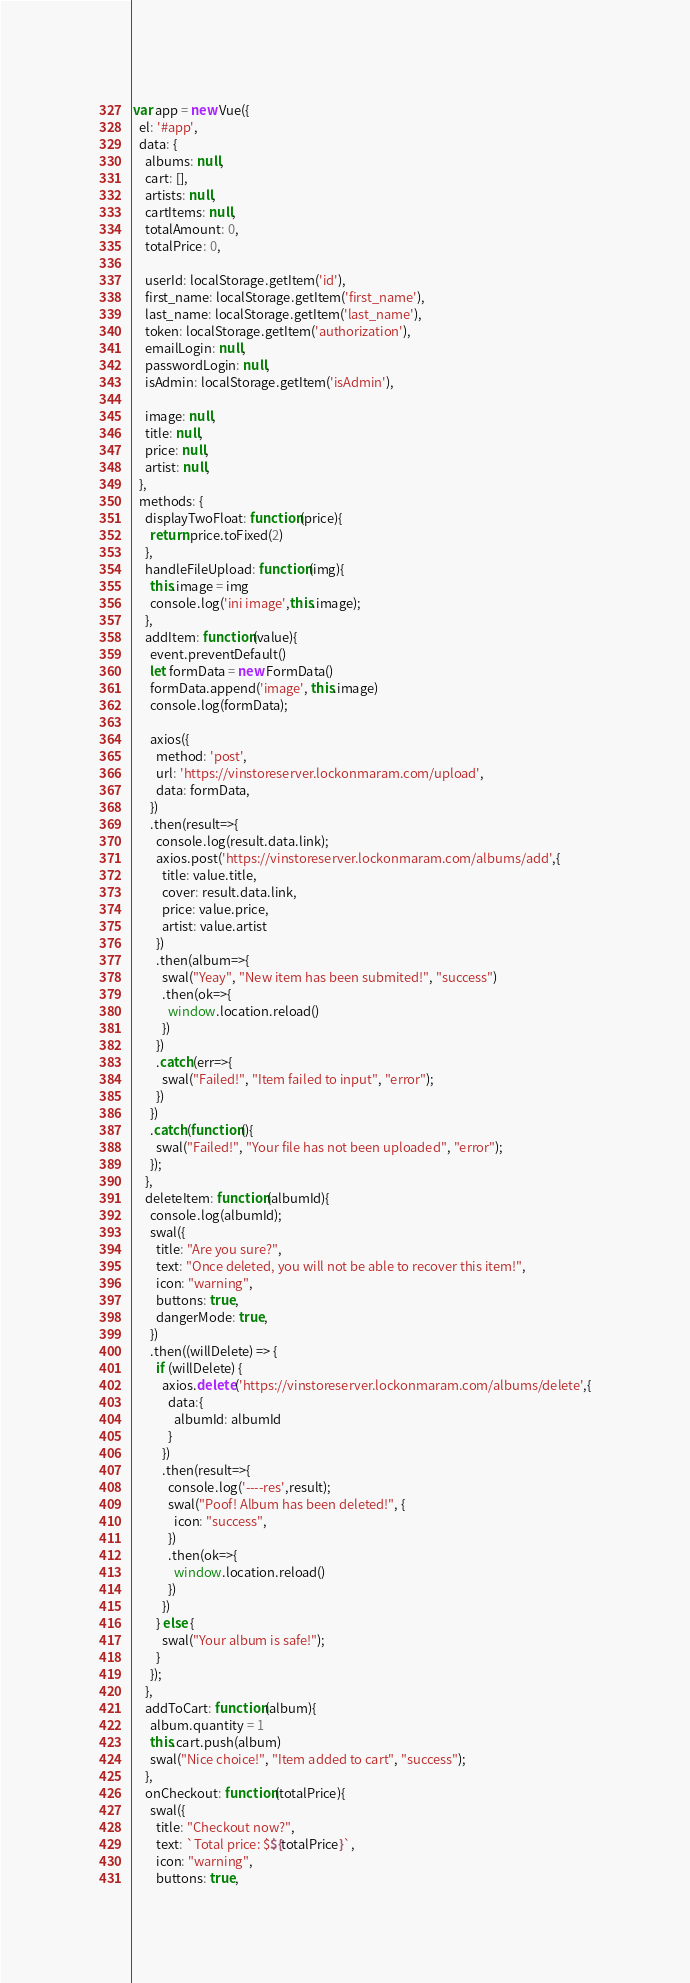<code> <loc_0><loc_0><loc_500><loc_500><_JavaScript_>var app = new Vue({
  el: '#app',
  data: {
    albums: null,
    cart: [],
    artists: null,
    cartItems: null,
    totalAmount: 0,
    totalPrice: 0,

    userId: localStorage.getItem('id'),
    first_name: localStorage.getItem('first_name'),
    last_name: localStorage.getItem('last_name'),
    token: localStorage.getItem('authorization'),
    emailLogin: null,
    passwordLogin: null,
    isAdmin: localStorage.getItem('isAdmin'),

    image: null,
    title: null,
    price: null,
    artist: null,
  },
  methods: {
    displayTwoFloat: function(price){
      return price.toFixed(2)
    },
    handleFileUpload: function(img){
      this.image = img
      console.log('ini image',this.image);
    },
    addItem: function(value){
      event.preventDefault()
      let formData = new FormData()
      formData.append('image', this.image)
      console.log(formData);

      axios({
        method: 'post',
        url: 'https://vinstoreserver.lockonmaram.com/upload',
        data: formData,
      })
      .then(result=>{
        console.log(result.data.link);
        axios.post('https://vinstoreserver.lockonmaram.com/albums/add',{
          title: value.title,
          cover: result.data.link,
          price: value.price,
          artist: value.artist
        })
        .then(album=>{
          swal("Yeay", "New item has been submited!", "success")
          .then(ok=>{
            window.location.reload()
          })
        })
        .catch(err=>{
          swal("Failed!", "Item failed to input", "error");
        })
      })
      .catch(function(){
        swal("Failed!", "Your file has not been uploaded", "error");
      });
    },
    deleteItem: function(albumId){
      console.log(albumId);
      swal({
        title: "Are you sure?",
        text: "Once deleted, you will not be able to recover this item!",
        icon: "warning",
        buttons: true,
        dangerMode: true,
      })
      .then((willDelete) => {
        if (willDelete) {
          axios.delete('https://vinstoreserver.lockonmaram.com/albums/delete',{
            data:{
              albumId: albumId
            }
          })
          .then(result=>{
            console.log('----res',result);
            swal("Poof! Album has been deleted!", {
              icon: "success",
            })
            .then(ok=>{
              window.location.reload()
            })
          })
        } else {
          swal("Your album is safe!");
        }
      });
    },
    addToCart: function(album){
      album.quantity = 1
      this.cart.push(album)
      swal("Nice choice!", "Item added to cart", "success");
    },
    onCheckout: function(totalPrice){
      swal({
        title: "Checkout now?",
        text: `Total price: $${totalPrice}`,
        icon: "warning",
        buttons: true,</code> 